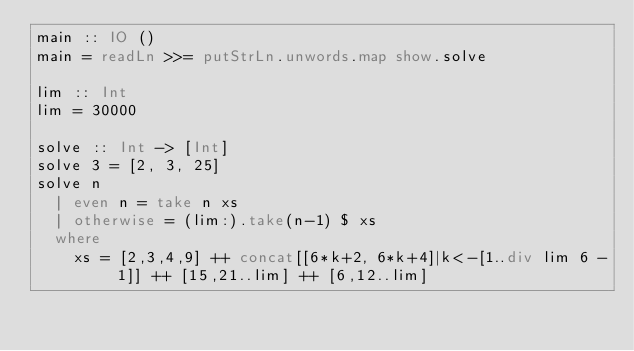<code> <loc_0><loc_0><loc_500><loc_500><_Haskell_>main :: IO ()
main = readLn >>= putStrLn.unwords.map show.solve

lim :: Int
lim = 30000

solve :: Int -> [Int]
solve 3 = [2, 3, 25]
solve n
  | even n = take n xs
  | otherwise = (lim:).take(n-1) $ xs
  where
    xs = [2,3,4,9] ++ concat[[6*k+2, 6*k+4]|k<-[1..div lim 6 - 1]] ++ [15,21..lim] ++ [6,12..lim]
</code> 